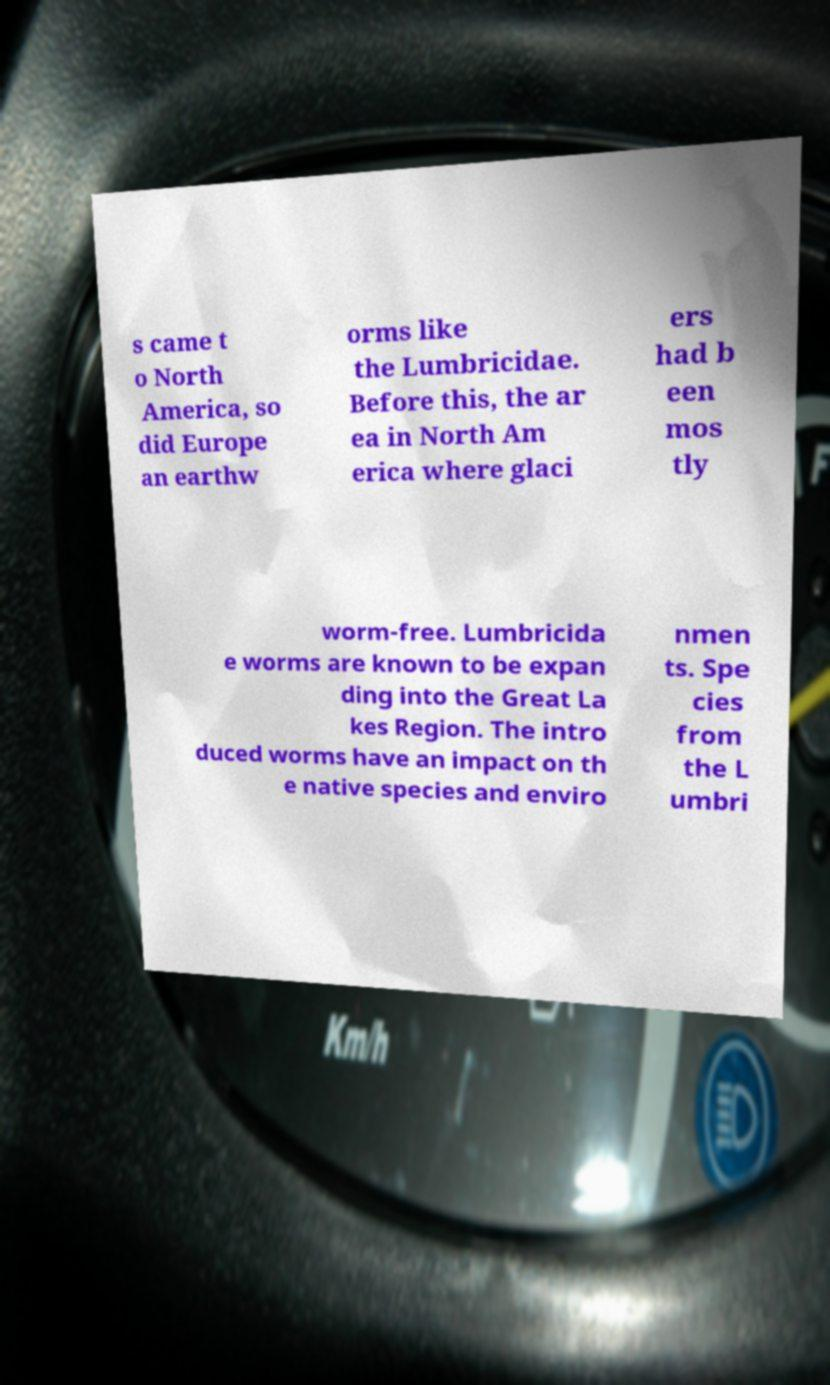Could you extract and type out the text from this image? s came t o North America, so did Europe an earthw orms like the Lumbricidae. Before this, the ar ea in North Am erica where glaci ers had b een mos tly worm-free. Lumbricida e worms are known to be expan ding into the Great La kes Region. The intro duced worms have an impact on th e native species and enviro nmen ts. Spe cies from the L umbri 